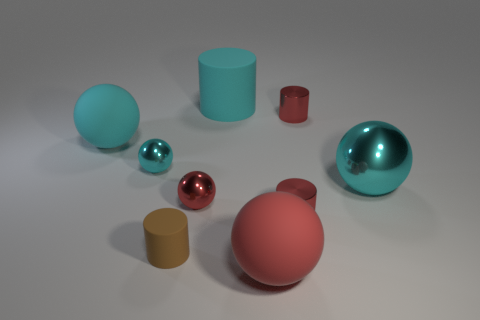What number of tiny objects are red things or cyan metallic objects?
Ensure brevity in your answer.  4. Is the number of big matte objects that are to the right of the tiny brown cylinder greater than the number of objects that are behind the big cylinder?
Ensure brevity in your answer.  Yes. Are the cyan cylinder and the large thing that is to the left of the tiny rubber thing made of the same material?
Your response must be concise. Yes. The large rubber cylinder is what color?
Make the answer very short. Cyan. The big cyan rubber object that is right of the tiny brown rubber cylinder has what shape?
Your answer should be very brief. Cylinder. What number of brown things are either metal objects or big cubes?
Keep it short and to the point. 0. The small sphere that is made of the same material as the small cyan thing is what color?
Your answer should be very brief. Red. Does the large metallic sphere have the same color as the large sphere that is on the left side of the cyan matte cylinder?
Make the answer very short. Yes. What color is the cylinder that is both behind the large metallic thing and in front of the large rubber cylinder?
Your answer should be very brief. Red. There is a large red object; what number of shiny things are to the left of it?
Ensure brevity in your answer.  2. 